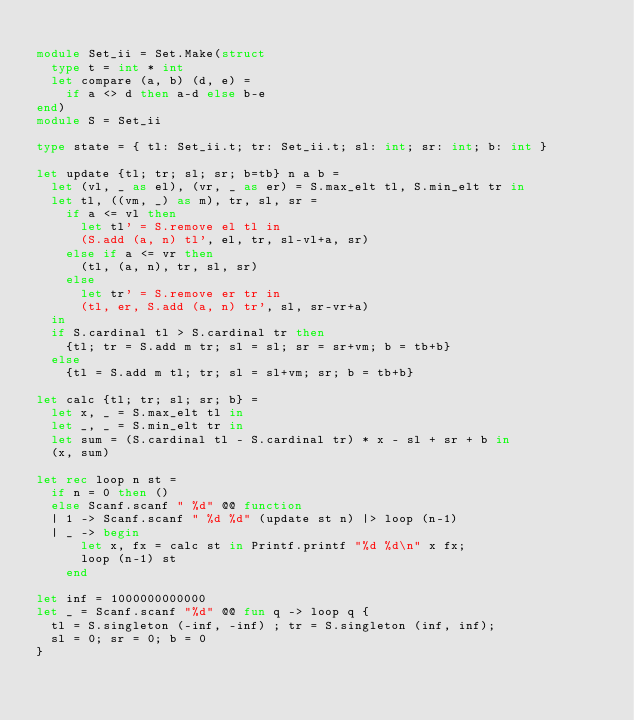<code> <loc_0><loc_0><loc_500><loc_500><_OCaml_>
module Set_ii = Set.Make(struct
  type t = int * int
  let compare (a, b) (d, e) =
    if a <> d then a-d else b-e
end)
module S = Set_ii

type state = { tl: Set_ii.t; tr: Set_ii.t; sl: int; sr: int; b: int }

let update {tl; tr; sl; sr; b=tb} n a b =
  let (vl, _ as el), (vr, _ as er) = S.max_elt tl, S.min_elt tr in
  let tl, ((vm, _) as m), tr, sl, sr =
    if a <= vl then
      let tl' = S.remove el tl in
      (S.add (a, n) tl', el, tr, sl-vl+a, sr)
    else if a <= vr then
      (tl, (a, n), tr, sl, sr)
    else
      let tr' = S.remove er tr in
      (tl, er, S.add (a, n) tr', sl, sr-vr+a)
  in
  if S.cardinal tl > S.cardinal tr then
    {tl; tr = S.add m tr; sl = sl; sr = sr+vm; b = tb+b}
  else
    {tl = S.add m tl; tr; sl = sl+vm; sr; b = tb+b}

let calc {tl; tr; sl; sr; b} =
  let x, _ = S.max_elt tl in
  let _, _ = S.min_elt tr in
  let sum = (S.cardinal tl - S.cardinal tr) * x - sl + sr + b in
  (x, sum)

let rec loop n st =
  if n = 0 then ()
  else Scanf.scanf " %d" @@ function
  | 1 -> Scanf.scanf " %d %d" (update st n) |> loop (n-1)
  | _ -> begin
      let x, fx = calc st in Printf.printf "%d %d\n" x fx;
      loop (n-1) st
    end

let inf = 1000000000000
let _ = Scanf.scanf "%d" @@ fun q -> loop q {
  tl = S.singleton (-inf, -inf) ; tr = S.singleton (inf, inf);
  sl = 0; sr = 0; b = 0
}
</code> 